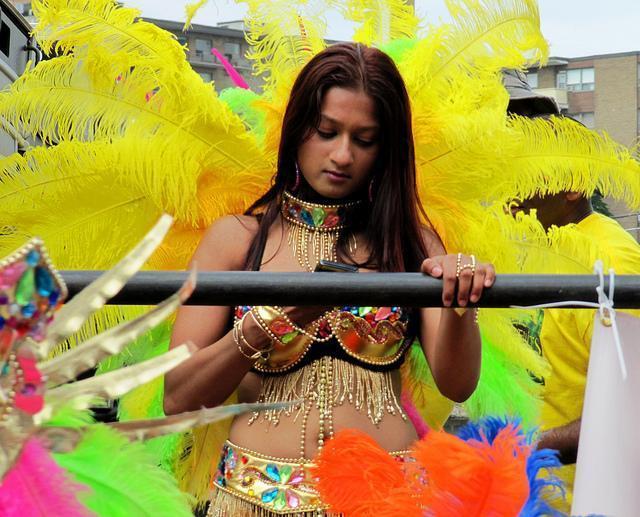How many ski lift chairs are visible?
Give a very brief answer. 0. 